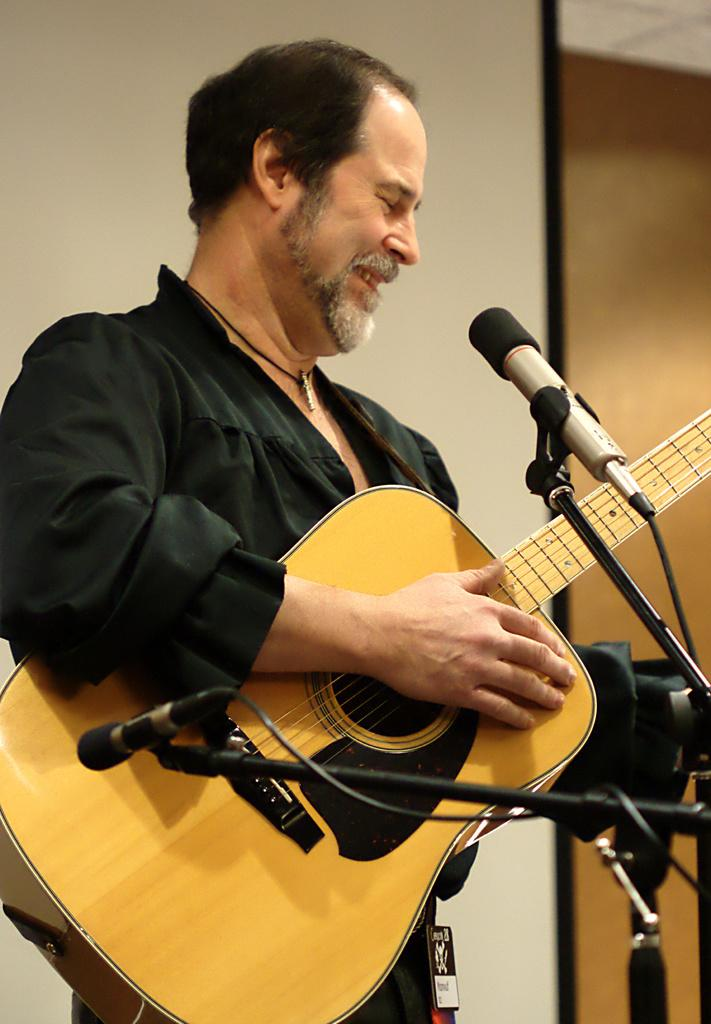What is the main subject of the image? There is a person in the image. What is the person doing in the image? The person is playing a guitar. How many microphones are visible in the image? There are two microphones in the image. Where is the person standing in relation to the microphones? The person is standing in front of the microphones. What can be seen behind the person? There is a wall behind the person. Can you tell me how many times the person's mother shakes her head in the image? There is no indication of the person's mother in the image, so it is not possible to determine how many times she shakes her head. 